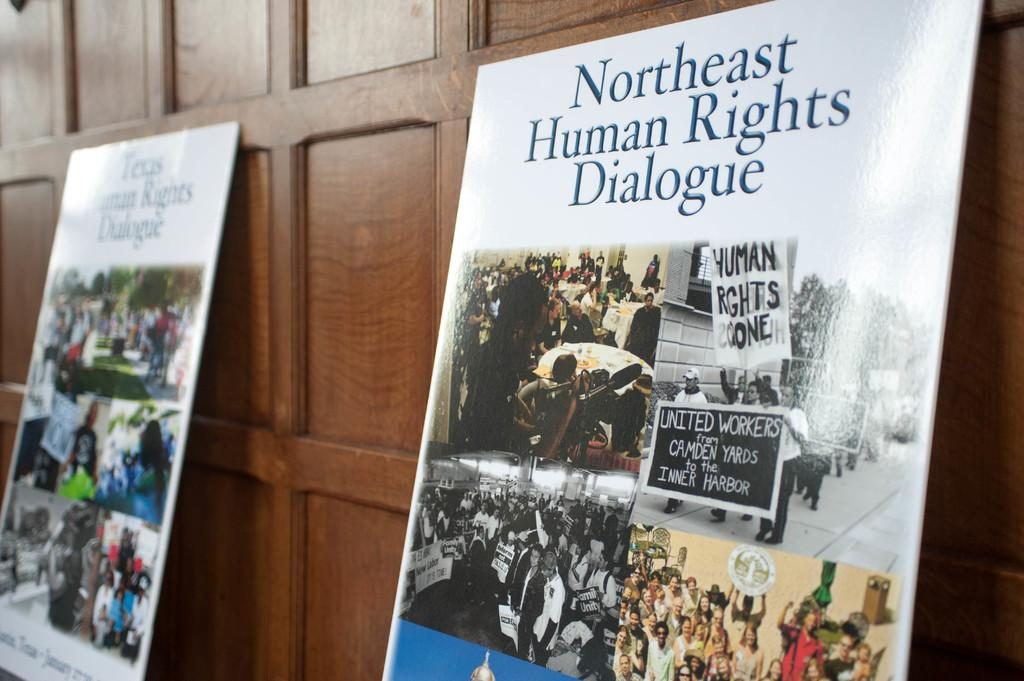<image>
Render a clear and concise summary of the photo. A board is propped on the wall with images of Northeast Human Rights  Dialogue. 